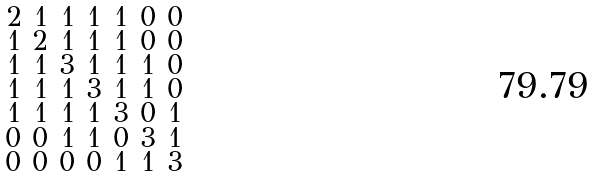Convert formula to latex. <formula><loc_0><loc_0><loc_500><loc_500>\begin{smallmatrix} 2 & 1 & 1 & 1 & 1 & 0 & 0 \\ 1 & 2 & 1 & 1 & 1 & 0 & 0 \\ 1 & 1 & 3 & 1 & 1 & 1 & 0 \\ 1 & 1 & 1 & 3 & 1 & 1 & 0 \\ 1 & 1 & 1 & 1 & 3 & 0 & 1 \\ 0 & 0 & 1 & 1 & 0 & 3 & 1 \\ 0 & 0 & 0 & 0 & 1 & 1 & 3 \end{smallmatrix}</formula> 